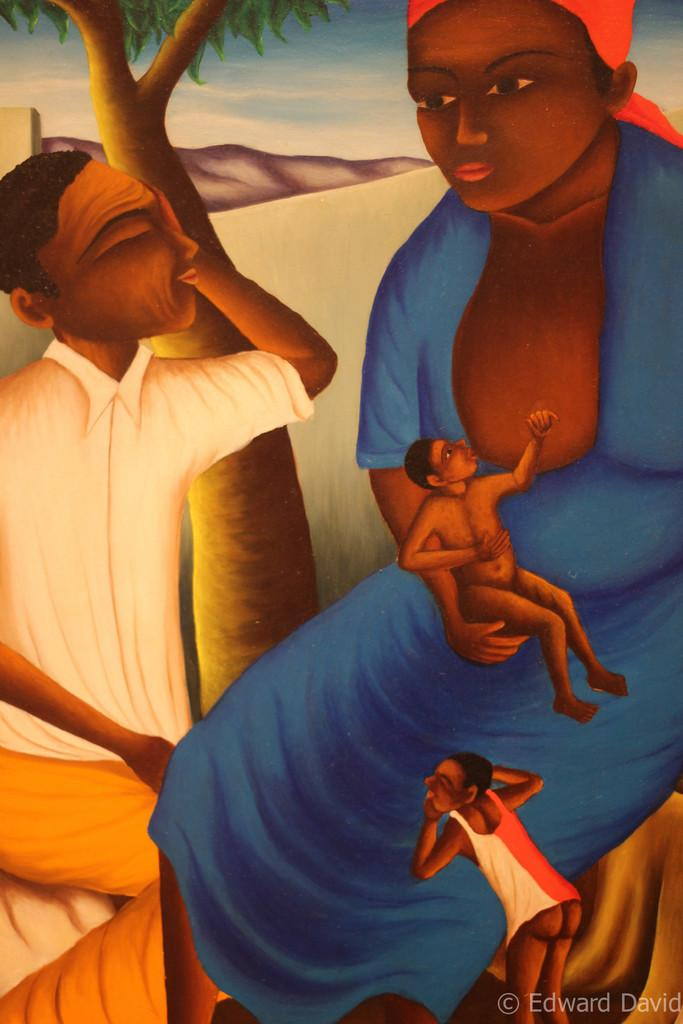What is the main subject of the image? The main subject of the image is a painting. What is depicted in the painting? The painting depicts people, a tree, a hill, and the sky. Where is the watermark located in the image? The watermark is in the bottom right side of the image. How many matches are visible in the painting? There are no matches depicted in the painting; it features people, a tree, a hill, and the sky. What type of spiders can be seen in the painting? There are no spiders present in the painting; it depicts people, a tree, a hill, and the sky. 